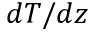<formula> <loc_0><loc_0><loc_500><loc_500>d T / d z</formula> 